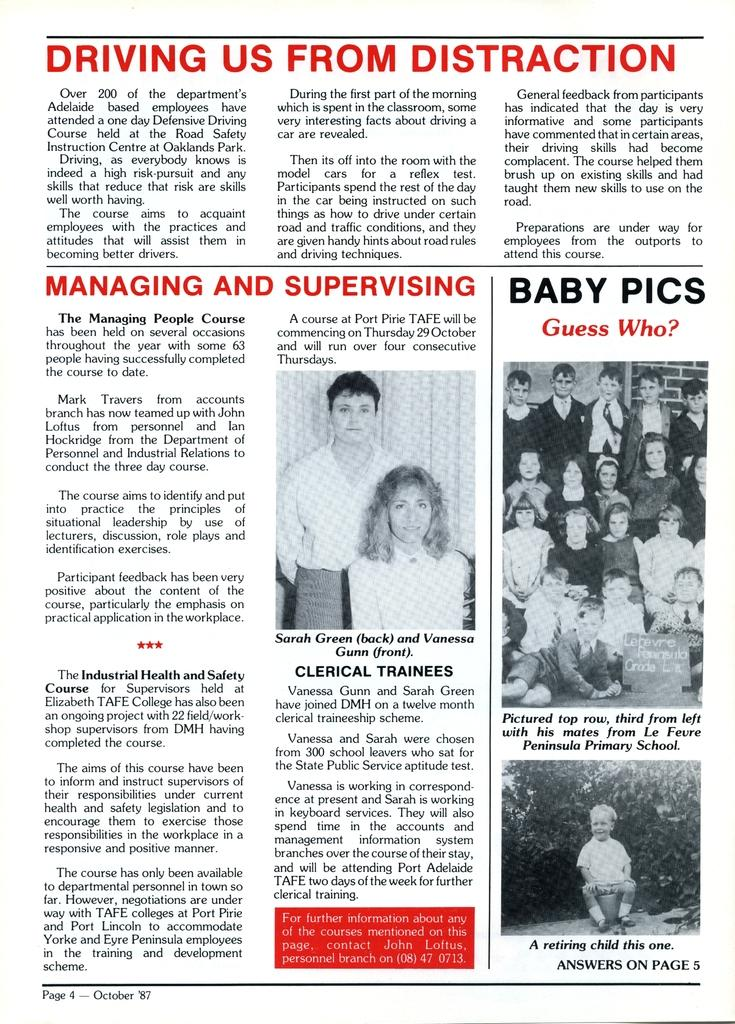What type of publication is visible in the image? There is a newspaper in the image. What can be found within the newspaper? The newspaper contains articles. How many leaves are scattered in the quicksand in the image? There is no quicksand or leaves present in the image; it only features a newspaper with articles. 